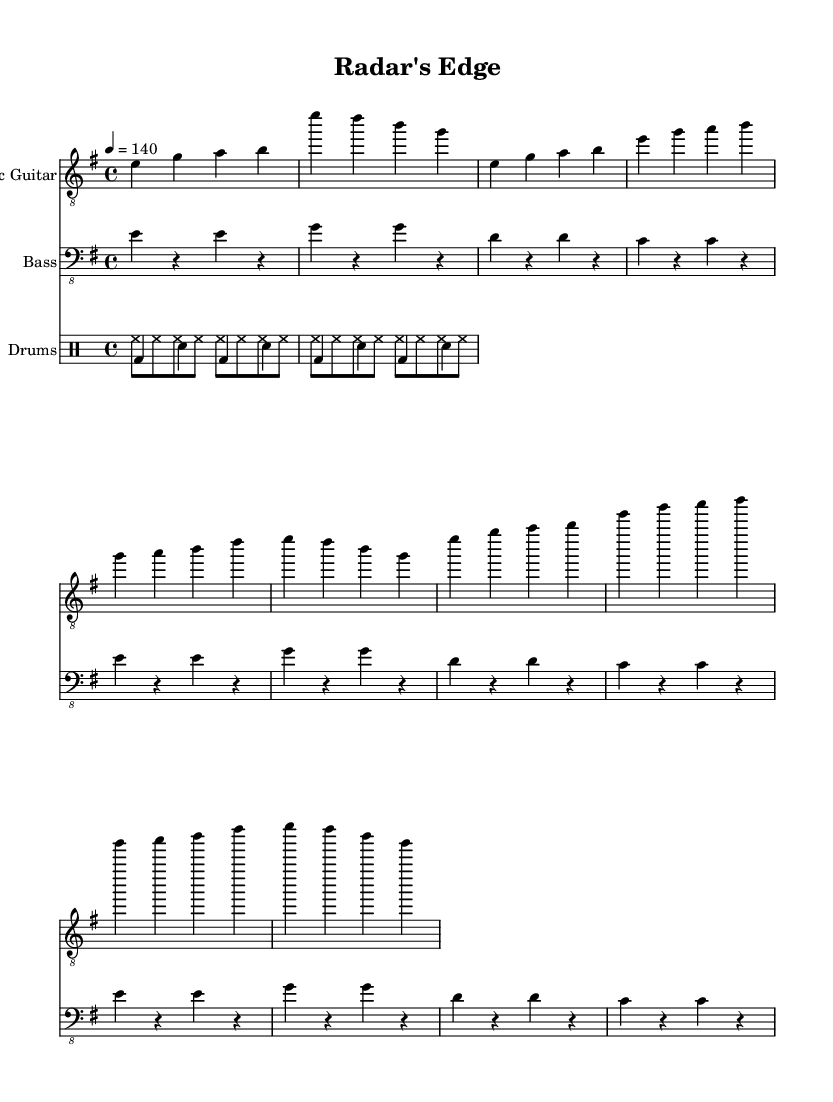What is the key signature of this music? The key signature indicated at the beginning of the score shows one sharp, which corresponds to E minor.
Answer: E minor What is the time signature of this music? The time signature is shown after the key signature, and it indicates that there are four beats in a measure (4/4).
Answer: 4/4 What is the tempo marking for this piece? The tempo marking at the start indicates that the music should be played at a speed of 140 beats per minute (bpm).
Answer: 140 How many measures are in the verse? The verse section consists of a repeated four-measure pattern, and since it is repeated twice, there are a total of eight measures in the verse.
Answer: 8 What instruments are included in this score? At the top of the score, there are three designated instruments: Electric Guitar, Bass, and Drums.
Answer: Electric Guitar, Bass, Drums What is the lyrical theme reflected in the chorus? The lyrics in the chorus talk about tracking movements and sealing fate, which reflects themes of surveillance and fate.
Answer: Surveillance and fate What does the term "DrumStaff" refer to in this music? The term "DrumStaff" indicates a designated staff for percussion instruments in the score, allowing for organized notation of drum parts.
Answer: Percussion instruments 